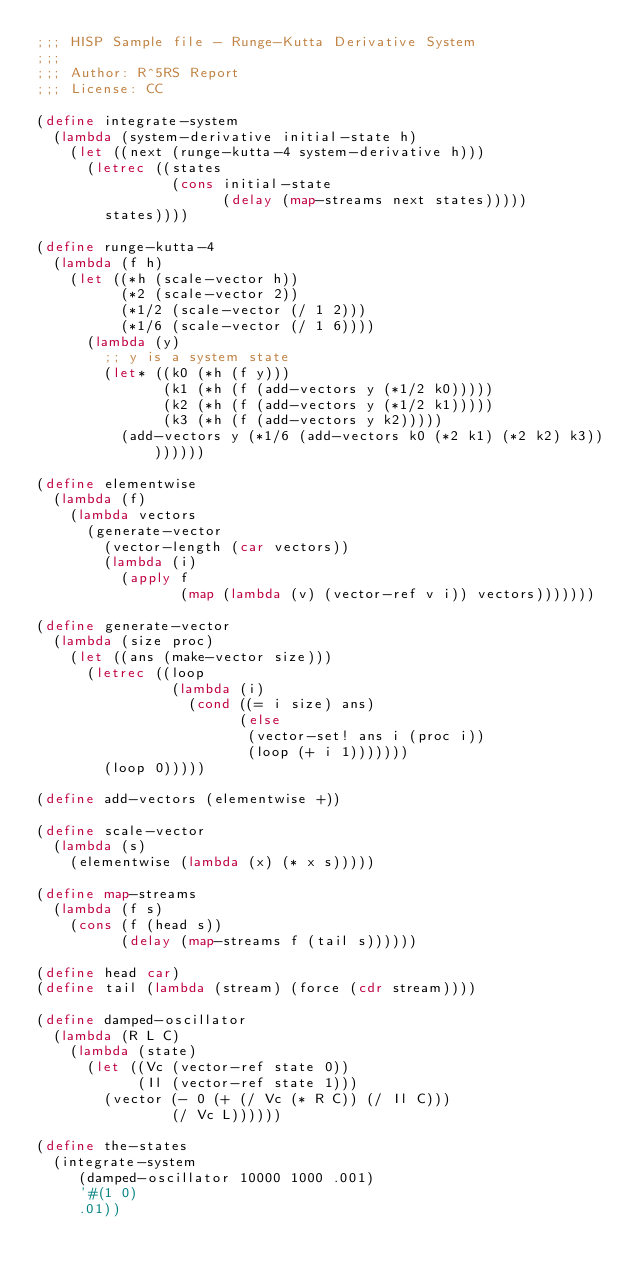Convert code to text. <code><loc_0><loc_0><loc_500><loc_500><_Scheme_>;;; HISP Sample file - Runge-Kutta Derivative System
;;;
;;; Author: R^5RS Report
;;; License: CC

(define integrate-system
  (lambda (system-derivative initial-state h)
	  (let ((next (runge-kutta-4 system-derivative h)))
		  (letrec ((states
								(cons initial-state
								      (delay (map-streams next states)))))
			  states))))

(define runge-kutta-4
  (lambda (f h)
	  (let ((*h (scale-vector h))
					(*2 (scale-vector 2))
					(*1/2 (scale-vector (/ 1 2)))
					(*1/6 (scale-vector (/ 1 6))))
		  (lambda (y)
			  ;; y is a system state
				(let* ((k0 (*h (f y)))
							 (k1 (*h (f (add-vectors y (*1/2 k0)))))
							 (k2 (*h (f (add-vectors y (*1/2 k1)))))
							 (k3 (*h (f (add-vectors y k2)))))
				  (add-vectors y (*1/6 (add-vectors k0 (*2 k1) (*2 k2) k3))))))))

(define elementwise
  (lambda (f)
	  (lambda vectors
		  (generate-vector
			  (vector-length (car vectors))
				(lambda (i)
				  (apply f
					       (map (lambda (v) (vector-ref v i)) vectors)))))))

(define generate-vector
  (lambda (size proc)
	  (let ((ans (make-vector size)))
		  (letrec ((loop
								(lambda (i)
								  (cond ((= i size) ans)
									      (else
												 (vector-set! ans i (proc i))
												 (loop (+ i 1)))))))
			  (loop 0)))))

(define add-vectors (elementwise +))

(define scale-vector
  (lambda (s)
	  (elementwise (lambda (x) (* x s)))))

(define map-streams
  (lambda (f s)
	  (cons (f (head s))
		      (delay (map-streams f (tail s))))))

(define head car)
(define tail (lambda (stream) (force (cdr stream))))

(define damped-oscillator
  (lambda (R L C)
	  (lambda (state)
		  (let ((Vc (vector-ref state 0))
						(Il (vector-ref state 1)))
			  (vector (- 0 (+ (/ Vc (* R C)) (/ Il C)))
				        (/ Vc L))))))

(define the-states
  (integrate-system
	   (damped-oscillator 10000 1000 .001)
		 '#(1 0)
		 .01))


</code> 